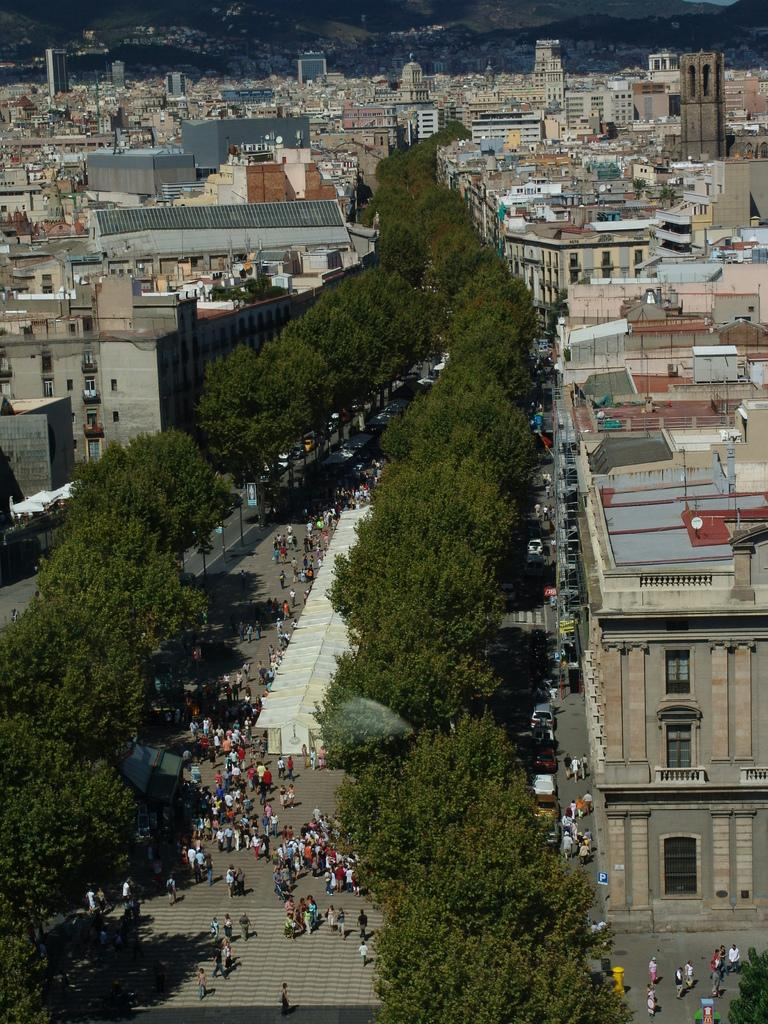What type of structures can be seen in the image? There are buildings in the image. What natural elements are present in the image? There are trees in the image. What objects are visible in the image that might be used for displaying information or advertisements? There are boards in the image. What type of transportation is present in the image? There are vehicles in the image. Are there any living beings visible in the image? Yes, there are people in the image. Can you tell me how many cards are being held by the people in the image? There is no mention of cards in the image, so it is not possible to determine if any are being held. What type of expert can be seen advising the people in the image? There is no expert present in the image; it only shows people, buildings, trees, boards, and vehicles. 